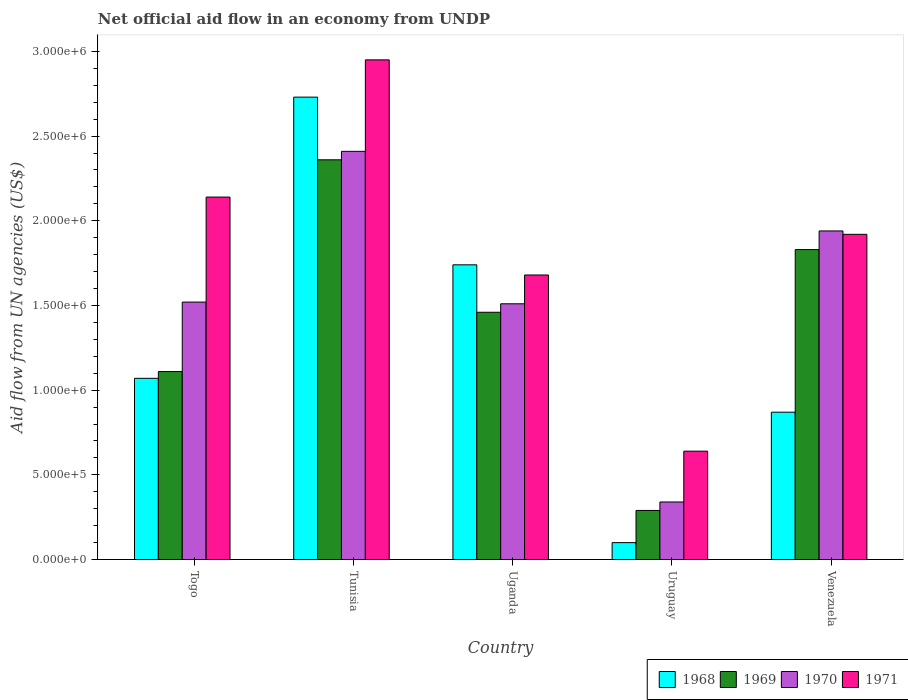How many different coloured bars are there?
Your response must be concise. 4. How many groups of bars are there?
Provide a short and direct response. 5. How many bars are there on the 4th tick from the left?
Your answer should be compact. 4. What is the label of the 5th group of bars from the left?
Provide a short and direct response. Venezuela. What is the net official aid flow in 1971 in Togo?
Ensure brevity in your answer.  2.14e+06. Across all countries, what is the maximum net official aid flow in 1969?
Ensure brevity in your answer.  2.36e+06. Across all countries, what is the minimum net official aid flow in 1971?
Your response must be concise. 6.40e+05. In which country was the net official aid flow in 1971 maximum?
Provide a succinct answer. Tunisia. In which country was the net official aid flow in 1970 minimum?
Offer a terse response. Uruguay. What is the total net official aid flow in 1968 in the graph?
Your answer should be compact. 6.51e+06. What is the difference between the net official aid flow in 1971 in Tunisia and that in Venezuela?
Offer a terse response. 1.03e+06. What is the difference between the net official aid flow in 1970 in Uganda and the net official aid flow in 1971 in Uruguay?
Make the answer very short. 8.70e+05. What is the average net official aid flow in 1968 per country?
Your response must be concise. 1.30e+06. What is the difference between the net official aid flow of/in 1969 and net official aid flow of/in 1971 in Uganda?
Ensure brevity in your answer.  -2.20e+05. What is the ratio of the net official aid flow in 1971 in Tunisia to that in Venezuela?
Offer a terse response. 1.54. Is the net official aid flow in 1968 in Uganda less than that in Venezuela?
Offer a terse response. No. Is the difference between the net official aid flow in 1969 in Togo and Uruguay greater than the difference between the net official aid flow in 1971 in Togo and Uruguay?
Your answer should be very brief. No. What is the difference between the highest and the second highest net official aid flow in 1971?
Offer a very short reply. 1.03e+06. What is the difference between the highest and the lowest net official aid flow in 1969?
Keep it short and to the point. 2.07e+06. Is the sum of the net official aid flow in 1971 in Tunisia and Uruguay greater than the maximum net official aid flow in 1969 across all countries?
Provide a succinct answer. Yes. Is it the case that in every country, the sum of the net official aid flow in 1969 and net official aid flow in 1968 is greater than the sum of net official aid flow in 1970 and net official aid flow in 1971?
Provide a succinct answer. No. What does the 3rd bar from the left in Uruguay represents?
Provide a short and direct response. 1970. Is it the case that in every country, the sum of the net official aid flow in 1969 and net official aid flow in 1970 is greater than the net official aid flow in 1968?
Provide a succinct answer. Yes. How many countries are there in the graph?
Your answer should be very brief. 5. What is the difference between two consecutive major ticks on the Y-axis?
Give a very brief answer. 5.00e+05. Does the graph contain any zero values?
Keep it short and to the point. No. Where does the legend appear in the graph?
Make the answer very short. Bottom right. How are the legend labels stacked?
Your answer should be compact. Horizontal. What is the title of the graph?
Ensure brevity in your answer.  Net official aid flow in an economy from UNDP. What is the label or title of the X-axis?
Your response must be concise. Country. What is the label or title of the Y-axis?
Your answer should be compact. Aid flow from UN agencies (US$). What is the Aid flow from UN agencies (US$) in 1968 in Togo?
Your answer should be very brief. 1.07e+06. What is the Aid flow from UN agencies (US$) in 1969 in Togo?
Your answer should be compact. 1.11e+06. What is the Aid flow from UN agencies (US$) in 1970 in Togo?
Make the answer very short. 1.52e+06. What is the Aid flow from UN agencies (US$) in 1971 in Togo?
Offer a very short reply. 2.14e+06. What is the Aid flow from UN agencies (US$) in 1968 in Tunisia?
Offer a terse response. 2.73e+06. What is the Aid flow from UN agencies (US$) in 1969 in Tunisia?
Your response must be concise. 2.36e+06. What is the Aid flow from UN agencies (US$) in 1970 in Tunisia?
Ensure brevity in your answer.  2.41e+06. What is the Aid flow from UN agencies (US$) of 1971 in Tunisia?
Keep it short and to the point. 2.95e+06. What is the Aid flow from UN agencies (US$) of 1968 in Uganda?
Ensure brevity in your answer.  1.74e+06. What is the Aid flow from UN agencies (US$) in 1969 in Uganda?
Offer a terse response. 1.46e+06. What is the Aid flow from UN agencies (US$) of 1970 in Uganda?
Provide a short and direct response. 1.51e+06. What is the Aid flow from UN agencies (US$) in 1971 in Uganda?
Provide a succinct answer. 1.68e+06. What is the Aid flow from UN agencies (US$) in 1968 in Uruguay?
Keep it short and to the point. 1.00e+05. What is the Aid flow from UN agencies (US$) of 1969 in Uruguay?
Offer a terse response. 2.90e+05. What is the Aid flow from UN agencies (US$) in 1970 in Uruguay?
Your response must be concise. 3.40e+05. What is the Aid flow from UN agencies (US$) of 1971 in Uruguay?
Your response must be concise. 6.40e+05. What is the Aid flow from UN agencies (US$) of 1968 in Venezuela?
Offer a terse response. 8.70e+05. What is the Aid flow from UN agencies (US$) in 1969 in Venezuela?
Your response must be concise. 1.83e+06. What is the Aid flow from UN agencies (US$) in 1970 in Venezuela?
Provide a short and direct response. 1.94e+06. What is the Aid flow from UN agencies (US$) in 1971 in Venezuela?
Offer a terse response. 1.92e+06. Across all countries, what is the maximum Aid flow from UN agencies (US$) in 1968?
Make the answer very short. 2.73e+06. Across all countries, what is the maximum Aid flow from UN agencies (US$) of 1969?
Your answer should be compact. 2.36e+06. Across all countries, what is the maximum Aid flow from UN agencies (US$) of 1970?
Offer a very short reply. 2.41e+06. Across all countries, what is the maximum Aid flow from UN agencies (US$) in 1971?
Ensure brevity in your answer.  2.95e+06. Across all countries, what is the minimum Aid flow from UN agencies (US$) in 1968?
Give a very brief answer. 1.00e+05. Across all countries, what is the minimum Aid flow from UN agencies (US$) of 1969?
Offer a very short reply. 2.90e+05. Across all countries, what is the minimum Aid flow from UN agencies (US$) in 1971?
Make the answer very short. 6.40e+05. What is the total Aid flow from UN agencies (US$) in 1968 in the graph?
Provide a succinct answer. 6.51e+06. What is the total Aid flow from UN agencies (US$) of 1969 in the graph?
Provide a succinct answer. 7.05e+06. What is the total Aid flow from UN agencies (US$) of 1970 in the graph?
Provide a succinct answer. 7.72e+06. What is the total Aid flow from UN agencies (US$) of 1971 in the graph?
Provide a short and direct response. 9.33e+06. What is the difference between the Aid flow from UN agencies (US$) in 1968 in Togo and that in Tunisia?
Offer a very short reply. -1.66e+06. What is the difference between the Aid flow from UN agencies (US$) of 1969 in Togo and that in Tunisia?
Give a very brief answer. -1.25e+06. What is the difference between the Aid flow from UN agencies (US$) in 1970 in Togo and that in Tunisia?
Give a very brief answer. -8.90e+05. What is the difference between the Aid flow from UN agencies (US$) of 1971 in Togo and that in Tunisia?
Provide a succinct answer. -8.10e+05. What is the difference between the Aid flow from UN agencies (US$) in 1968 in Togo and that in Uganda?
Provide a short and direct response. -6.70e+05. What is the difference between the Aid flow from UN agencies (US$) of 1969 in Togo and that in Uganda?
Your response must be concise. -3.50e+05. What is the difference between the Aid flow from UN agencies (US$) in 1970 in Togo and that in Uganda?
Make the answer very short. 10000. What is the difference between the Aid flow from UN agencies (US$) in 1971 in Togo and that in Uganda?
Provide a short and direct response. 4.60e+05. What is the difference between the Aid flow from UN agencies (US$) of 1968 in Togo and that in Uruguay?
Provide a succinct answer. 9.70e+05. What is the difference between the Aid flow from UN agencies (US$) in 1969 in Togo and that in Uruguay?
Your answer should be compact. 8.20e+05. What is the difference between the Aid flow from UN agencies (US$) in 1970 in Togo and that in Uruguay?
Keep it short and to the point. 1.18e+06. What is the difference between the Aid flow from UN agencies (US$) in 1971 in Togo and that in Uruguay?
Your answer should be very brief. 1.50e+06. What is the difference between the Aid flow from UN agencies (US$) of 1969 in Togo and that in Venezuela?
Your answer should be compact. -7.20e+05. What is the difference between the Aid flow from UN agencies (US$) of 1970 in Togo and that in Venezuela?
Give a very brief answer. -4.20e+05. What is the difference between the Aid flow from UN agencies (US$) in 1968 in Tunisia and that in Uganda?
Keep it short and to the point. 9.90e+05. What is the difference between the Aid flow from UN agencies (US$) of 1970 in Tunisia and that in Uganda?
Provide a succinct answer. 9.00e+05. What is the difference between the Aid flow from UN agencies (US$) of 1971 in Tunisia and that in Uganda?
Your answer should be compact. 1.27e+06. What is the difference between the Aid flow from UN agencies (US$) in 1968 in Tunisia and that in Uruguay?
Your answer should be very brief. 2.63e+06. What is the difference between the Aid flow from UN agencies (US$) in 1969 in Tunisia and that in Uruguay?
Make the answer very short. 2.07e+06. What is the difference between the Aid flow from UN agencies (US$) of 1970 in Tunisia and that in Uruguay?
Ensure brevity in your answer.  2.07e+06. What is the difference between the Aid flow from UN agencies (US$) of 1971 in Tunisia and that in Uruguay?
Your answer should be very brief. 2.31e+06. What is the difference between the Aid flow from UN agencies (US$) of 1968 in Tunisia and that in Venezuela?
Your answer should be very brief. 1.86e+06. What is the difference between the Aid flow from UN agencies (US$) in 1969 in Tunisia and that in Venezuela?
Ensure brevity in your answer.  5.30e+05. What is the difference between the Aid flow from UN agencies (US$) of 1971 in Tunisia and that in Venezuela?
Ensure brevity in your answer.  1.03e+06. What is the difference between the Aid flow from UN agencies (US$) in 1968 in Uganda and that in Uruguay?
Keep it short and to the point. 1.64e+06. What is the difference between the Aid flow from UN agencies (US$) in 1969 in Uganda and that in Uruguay?
Keep it short and to the point. 1.17e+06. What is the difference between the Aid flow from UN agencies (US$) in 1970 in Uganda and that in Uruguay?
Make the answer very short. 1.17e+06. What is the difference between the Aid flow from UN agencies (US$) in 1971 in Uganda and that in Uruguay?
Offer a very short reply. 1.04e+06. What is the difference between the Aid flow from UN agencies (US$) in 1968 in Uganda and that in Venezuela?
Offer a very short reply. 8.70e+05. What is the difference between the Aid flow from UN agencies (US$) of 1969 in Uganda and that in Venezuela?
Offer a very short reply. -3.70e+05. What is the difference between the Aid flow from UN agencies (US$) of 1970 in Uganda and that in Venezuela?
Make the answer very short. -4.30e+05. What is the difference between the Aid flow from UN agencies (US$) of 1968 in Uruguay and that in Venezuela?
Your answer should be compact. -7.70e+05. What is the difference between the Aid flow from UN agencies (US$) in 1969 in Uruguay and that in Venezuela?
Your answer should be compact. -1.54e+06. What is the difference between the Aid flow from UN agencies (US$) in 1970 in Uruguay and that in Venezuela?
Ensure brevity in your answer.  -1.60e+06. What is the difference between the Aid flow from UN agencies (US$) of 1971 in Uruguay and that in Venezuela?
Provide a succinct answer. -1.28e+06. What is the difference between the Aid flow from UN agencies (US$) in 1968 in Togo and the Aid flow from UN agencies (US$) in 1969 in Tunisia?
Give a very brief answer. -1.29e+06. What is the difference between the Aid flow from UN agencies (US$) of 1968 in Togo and the Aid flow from UN agencies (US$) of 1970 in Tunisia?
Ensure brevity in your answer.  -1.34e+06. What is the difference between the Aid flow from UN agencies (US$) of 1968 in Togo and the Aid flow from UN agencies (US$) of 1971 in Tunisia?
Your response must be concise. -1.88e+06. What is the difference between the Aid flow from UN agencies (US$) of 1969 in Togo and the Aid flow from UN agencies (US$) of 1970 in Tunisia?
Offer a terse response. -1.30e+06. What is the difference between the Aid flow from UN agencies (US$) of 1969 in Togo and the Aid flow from UN agencies (US$) of 1971 in Tunisia?
Offer a very short reply. -1.84e+06. What is the difference between the Aid flow from UN agencies (US$) of 1970 in Togo and the Aid flow from UN agencies (US$) of 1971 in Tunisia?
Your answer should be compact. -1.43e+06. What is the difference between the Aid flow from UN agencies (US$) in 1968 in Togo and the Aid flow from UN agencies (US$) in 1969 in Uganda?
Make the answer very short. -3.90e+05. What is the difference between the Aid flow from UN agencies (US$) of 1968 in Togo and the Aid flow from UN agencies (US$) of 1970 in Uganda?
Give a very brief answer. -4.40e+05. What is the difference between the Aid flow from UN agencies (US$) in 1968 in Togo and the Aid flow from UN agencies (US$) in 1971 in Uganda?
Offer a terse response. -6.10e+05. What is the difference between the Aid flow from UN agencies (US$) in 1969 in Togo and the Aid flow from UN agencies (US$) in 1970 in Uganda?
Give a very brief answer. -4.00e+05. What is the difference between the Aid flow from UN agencies (US$) of 1969 in Togo and the Aid flow from UN agencies (US$) of 1971 in Uganda?
Offer a terse response. -5.70e+05. What is the difference between the Aid flow from UN agencies (US$) in 1970 in Togo and the Aid flow from UN agencies (US$) in 1971 in Uganda?
Give a very brief answer. -1.60e+05. What is the difference between the Aid flow from UN agencies (US$) in 1968 in Togo and the Aid flow from UN agencies (US$) in 1969 in Uruguay?
Your answer should be very brief. 7.80e+05. What is the difference between the Aid flow from UN agencies (US$) of 1968 in Togo and the Aid flow from UN agencies (US$) of 1970 in Uruguay?
Your answer should be compact. 7.30e+05. What is the difference between the Aid flow from UN agencies (US$) in 1969 in Togo and the Aid flow from UN agencies (US$) in 1970 in Uruguay?
Your answer should be compact. 7.70e+05. What is the difference between the Aid flow from UN agencies (US$) in 1969 in Togo and the Aid flow from UN agencies (US$) in 1971 in Uruguay?
Offer a terse response. 4.70e+05. What is the difference between the Aid flow from UN agencies (US$) in 1970 in Togo and the Aid flow from UN agencies (US$) in 1971 in Uruguay?
Give a very brief answer. 8.80e+05. What is the difference between the Aid flow from UN agencies (US$) in 1968 in Togo and the Aid flow from UN agencies (US$) in 1969 in Venezuela?
Your answer should be very brief. -7.60e+05. What is the difference between the Aid flow from UN agencies (US$) of 1968 in Togo and the Aid flow from UN agencies (US$) of 1970 in Venezuela?
Give a very brief answer. -8.70e+05. What is the difference between the Aid flow from UN agencies (US$) in 1968 in Togo and the Aid flow from UN agencies (US$) in 1971 in Venezuela?
Ensure brevity in your answer.  -8.50e+05. What is the difference between the Aid flow from UN agencies (US$) of 1969 in Togo and the Aid flow from UN agencies (US$) of 1970 in Venezuela?
Your answer should be compact. -8.30e+05. What is the difference between the Aid flow from UN agencies (US$) in 1969 in Togo and the Aid flow from UN agencies (US$) in 1971 in Venezuela?
Your response must be concise. -8.10e+05. What is the difference between the Aid flow from UN agencies (US$) of 1970 in Togo and the Aid flow from UN agencies (US$) of 1971 in Venezuela?
Your answer should be very brief. -4.00e+05. What is the difference between the Aid flow from UN agencies (US$) of 1968 in Tunisia and the Aid flow from UN agencies (US$) of 1969 in Uganda?
Keep it short and to the point. 1.27e+06. What is the difference between the Aid flow from UN agencies (US$) of 1968 in Tunisia and the Aid flow from UN agencies (US$) of 1970 in Uganda?
Keep it short and to the point. 1.22e+06. What is the difference between the Aid flow from UN agencies (US$) of 1968 in Tunisia and the Aid flow from UN agencies (US$) of 1971 in Uganda?
Make the answer very short. 1.05e+06. What is the difference between the Aid flow from UN agencies (US$) in 1969 in Tunisia and the Aid flow from UN agencies (US$) in 1970 in Uganda?
Ensure brevity in your answer.  8.50e+05. What is the difference between the Aid flow from UN agencies (US$) of 1969 in Tunisia and the Aid flow from UN agencies (US$) of 1971 in Uganda?
Your answer should be very brief. 6.80e+05. What is the difference between the Aid flow from UN agencies (US$) of 1970 in Tunisia and the Aid flow from UN agencies (US$) of 1971 in Uganda?
Make the answer very short. 7.30e+05. What is the difference between the Aid flow from UN agencies (US$) of 1968 in Tunisia and the Aid flow from UN agencies (US$) of 1969 in Uruguay?
Make the answer very short. 2.44e+06. What is the difference between the Aid flow from UN agencies (US$) of 1968 in Tunisia and the Aid flow from UN agencies (US$) of 1970 in Uruguay?
Your answer should be very brief. 2.39e+06. What is the difference between the Aid flow from UN agencies (US$) of 1968 in Tunisia and the Aid flow from UN agencies (US$) of 1971 in Uruguay?
Your response must be concise. 2.09e+06. What is the difference between the Aid flow from UN agencies (US$) in 1969 in Tunisia and the Aid flow from UN agencies (US$) in 1970 in Uruguay?
Keep it short and to the point. 2.02e+06. What is the difference between the Aid flow from UN agencies (US$) of 1969 in Tunisia and the Aid flow from UN agencies (US$) of 1971 in Uruguay?
Your answer should be compact. 1.72e+06. What is the difference between the Aid flow from UN agencies (US$) in 1970 in Tunisia and the Aid flow from UN agencies (US$) in 1971 in Uruguay?
Ensure brevity in your answer.  1.77e+06. What is the difference between the Aid flow from UN agencies (US$) of 1968 in Tunisia and the Aid flow from UN agencies (US$) of 1970 in Venezuela?
Give a very brief answer. 7.90e+05. What is the difference between the Aid flow from UN agencies (US$) of 1968 in Tunisia and the Aid flow from UN agencies (US$) of 1971 in Venezuela?
Provide a short and direct response. 8.10e+05. What is the difference between the Aid flow from UN agencies (US$) of 1969 in Tunisia and the Aid flow from UN agencies (US$) of 1970 in Venezuela?
Offer a very short reply. 4.20e+05. What is the difference between the Aid flow from UN agencies (US$) in 1969 in Tunisia and the Aid flow from UN agencies (US$) in 1971 in Venezuela?
Offer a very short reply. 4.40e+05. What is the difference between the Aid flow from UN agencies (US$) in 1970 in Tunisia and the Aid flow from UN agencies (US$) in 1971 in Venezuela?
Make the answer very short. 4.90e+05. What is the difference between the Aid flow from UN agencies (US$) of 1968 in Uganda and the Aid flow from UN agencies (US$) of 1969 in Uruguay?
Ensure brevity in your answer.  1.45e+06. What is the difference between the Aid flow from UN agencies (US$) of 1968 in Uganda and the Aid flow from UN agencies (US$) of 1970 in Uruguay?
Your answer should be compact. 1.40e+06. What is the difference between the Aid flow from UN agencies (US$) of 1968 in Uganda and the Aid flow from UN agencies (US$) of 1971 in Uruguay?
Your answer should be compact. 1.10e+06. What is the difference between the Aid flow from UN agencies (US$) of 1969 in Uganda and the Aid flow from UN agencies (US$) of 1970 in Uruguay?
Give a very brief answer. 1.12e+06. What is the difference between the Aid flow from UN agencies (US$) of 1969 in Uganda and the Aid flow from UN agencies (US$) of 1971 in Uruguay?
Keep it short and to the point. 8.20e+05. What is the difference between the Aid flow from UN agencies (US$) in 1970 in Uganda and the Aid flow from UN agencies (US$) in 1971 in Uruguay?
Your answer should be very brief. 8.70e+05. What is the difference between the Aid flow from UN agencies (US$) of 1968 in Uganda and the Aid flow from UN agencies (US$) of 1971 in Venezuela?
Give a very brief answer. -1.80e+05. What is the difference between the Aid flow from UN agencies (US$) in 1969 in Uganda and the Aid flow from UN agencies (US$) in 1970 in Venezuela?
Your answer should be very brief. -4.80e+05. What is the difference between the Aid flow from UN agencies (US$) in 1969 in Uganda and the Aid flow from UN agencies (US$) in 1971 in Venezuela?
Your response must be concise. -4.60e+05. What is the difference between the Aid flow from UN agencies (US$) of 1970 in Uganda and the Aid flow from UN agencies (US$) of 1971 in Venezuela?
Keep it short and to the point. -4.10e+05. What is the difference between the Aid flow from UN agencies (US$) in 1968 in Uruguay and the Aid flow from UN agencies (US$) in 1969 in Venezuela?
Keep it short and to the point. -1.73e+06. What is the difference between the Aid flow from UN agencies (US$) in 1968 in Uruguay and the Aid flow from UN agencies (US$) in 1970 in Venezuela?
Provide a succinct answer. -1.84e+06. What is the difference between the Aid flow from UN agencies (US$) in 1968 in Uruguay and the Aid flow from UN agencies (US$) in 1971 in Venezuela?
Your response must be concise. -1.82e+06. What is the difference between the Aid flow from UN agencies (US$) of 1969 in Uruguay and the Aid flow from UN agencies (US$) of 1970 in Venezuela?
Provide a short and direct response. -1.65e+06. What is the difference between the Aid flow from UN agencies (US$) of 1969 in Uruguay and the Aid flow from UN agencies (US$) of 1971 in Venezuela?
Provide a succinct answer. -1.63e+06. What is the difference between the Aid flow from UN agencies (US$) in 1970 in Uruguay and the Aid flow from UN agencies (US$) in 1971 in Venezuela?
Keep it short and to the point. -1.58e+06. What is the average Aid flow from UN agencies (US$) of 1968 per country?
Provide a short and direct response. 1.30e+06. What is the average Aid flow from UN agencies (US$) in 1969 per country?
Offer a terse response. 1.41e+06. What is the average Aid flow from UN agencies (US$) of 1970 per country?
Make the answer very short. 1.54e+06. What is the average Aid flow from UN agencies (US$) of 1971 per country?
Offer a terse response. 1.87e+06. What is the difference between the Aid flow from UN agencies (US$) of 1968 and Aid flow from UN agencies (US$) of 1970 in Togo?
Your response must be concise. -4.50e+05. What is the difference between the Aid flow from UN agencies (US$) of 1968 and Aid flow from UN agencies (US$) of 1971 in Togo?
Provide a succinct answer. -1.07e+06. What is the difference between the Aid flow from UN agencies (US$) in 1969 and Aid flow from UN agencies (US$) in 1970 in Togo?
Your response must be concise. -4.10e+05. What is the difference between the Aid flow from UN agencies (US$) in 1969 and Aid flow from UN agencies (US$) in 1971 in Togo?
Make the answer very short. -1.03e+06. What is the difference between the Aid flow from UN agencies (US$) in 1970 and Aid flow from UN agencies (US$) in 1971 in Togo?
Give a very brief answer. -6.20e+05. What is the difference between the Aid flow from UN agencies (US$) in 1968 and Aid flow from UN agencies (US$) in 1970 in Tunisia?
Offer a very short reply. 3.20e+05. What is the difference between the Aid flow from UN agencies (US$) of 1968 and Aid flow from UN agencies (US$) of 1971 in Tunisia?
Give a very brief answer. -2.20e+05. What is the difference between the Aid flow from UN agencies (US$) of 1969 and Aid flow from UN agencies (US$) of 1971 in Tunisia?
Your response must be concise. -5.90e+05. What is the difference between the Aid flow from UN agencies (US$) in 1970 and Aid flow from UN agencies (US$) in 1971 in Tunisia?
Offer a terse response. -5.40e+05. What is the difference between the Aid flow from UN agencies (US$) in 1968 and Aid flow from UN agencies (US$) in 1969 in Uganda?
Offer a very short reply. 2.80e+05. What is the difference between the Aid flow from UN agencies (US$) in 1968 and Aid flow from UN agencies (US$) in 1971 in Uganda?
Give a very brief answer. 6.00e+04. What is the difference between the Aid flow from UN agencies (US$) in 1969 and Aid flow from UN agencies (US$) in 1970 in Uganda?
Ensure brevity in your answer.  -5.00e+04. What is the difference between the Aid flow from UN agencies (US$) of 1969 and Aid flow from UN agencies (US$) of 1971 in Uganda?
Your answer should be compact. -2.20e+05. What is the difference between the Aid flow from UN agencies (US$) in 1970 and Aid flow from UN agencies (US$) in 1971 in Uganda?
Ensure brevity in your answer.  -1.70e+05. What is the difference between the Aid flow from UN agencies (US$) of 1968 and Aid flow from UN agencies (US$) of 1970 in Uruguay?
Provide a succinct answer. -2.40e+05. What is the difference between the Aid flow from UN agencies (US$) of 1968 and Aid flow from UN agencies (US$) of 1971 in Uruguay?
Your answer should be compact. -5.40e+05. What is the difference between the Aid flow from UN agencies (US$) in 1969 and Aid flow from UN agencies (US$) in 1971 in Uruguay?
Provide a succinct answer. -3.50e+05. What is the difference between the Aid flow from UN agencies (US$) of 1970 and Aid flow from UN agencies (US$) of 1971 in Uruguay?
Provide a succinct answer. -3.00e+05. What is the difference between the Aid flow from UN agencies (US$) of 1968 and Aid flow from UN agencies (US$) of 1969 in Venezuela?
Offer a terse response. -9.60e+05. What is the difference between the Aid flow from UN agencies (US$) in 1968 and Aid flow from UN agencies (US$) in 1970 in Venezuela?
Offer a terse response. -1.07e+06. What is the difference between the Aid flow from UN agencies (US$) of 1968 and Aid flow from UN agencies (US$) of 1971 in Venezuela?
Provide a succinct answer. -1.05e+06. What is the difference between the Aid flow from UN agencies (US$) in 1969 and Aid flow from UN agencies (US$) in 1970 in Venezuela?
Offer a terse response. -1.10e+05. What is the difference between the Aid flow from UN agencies (US$) of 1969 and Aid flow from UN agencies (US$) of 1971 in Venezuela?
Give a very brief answer. -9.00e+04. What is the ratio of the Aid flow from UN agencies (US$) of 1968 in Togo to that in Tunisia?
Ensure brevity in your answer.  0.39. What is the ratio of the Aid flow from UN agencies (US$) in 1969 in Togo to that in Tunisia?
Give a very brief answer. 0.47. What is the ratio of the Aid flow from UN agencies (US$) of 1970 in Togo to that in Tunisia?
Provide a succinct answer. 0.63. What is the ratio of the Aid flow from UN agencies (US$) of 1971 in Togo to that in Tunisia?
Offer a terse response. 0.73. What is the ratio of the Aid flow from UN agencies (US$) in 1968 in Togo to that in Uganda?
Offer a very short reply. 0.61. What is the ratio of the Aid flow from UN agencies (US$) of 1969 in Togo to that in Uganda?
Make the answer very short. 0.76. What is the ratio of the Aid flow from UN agencies (US$) in 1970 in Togo to that in Uganda?
Make the answer very short. 1.01. What is the ratio of the Aid flow from UN agencies (US$) of 1971 in Togo to that in Uganda?
Your answer should be very brief. 1.27. What is the ratio of the Aid flow from UN agencies (US$) of 1968 in Togo to that in Uruguay?
Your answer should be compact. 10.7. What is the ratio of the Aid flow from UN agencies (US$) of 1969 in Togo to that in Uruguay?
Offer a terse response. 3.83. What is the ratio of the Aid flow from UN agencies (US$) in 1970 in Togo to that in Uruguay?
Your answer should be compact. 4.47. What is the ratio of the Aid flow from UN agencies (US$) in 1971 in Togo to that in Uruguay?
Keep it short and to the point. 3.34. What is the ratio of the Aid flow from UN agencies (US$) in 1968 in Togo to that in Venezuela?
Provide a short and direct response. 1.23. What is the ratio of the Aid flow from UN agencies (US$) in 1969 in Togo to that in Venezuela?
Give a very brief answer. 0.61. What is the ratio of the Aid flow from UN agencies (US$) of 1970 in Togo to that in Venezuela?
Your response must be concise. 0.78. What is the ratio of the Aid flow from UN agencies (US$) of 1971 in Togo to that in Venezuela?
Provide a short and direct response. 1.11. What is the ratio of the Aid flow from UN agencies (US$) of 1968 in Tunisia to that in Uganda?
Keep it short and to the point. 1.57. What is the ratio of the Aid flow from UN agencies (US$) of 1969 in Tunisia to that in Uganda?
Provide a short and direct response. 1.62. What is the ratio of the Aid flow from UN agencies (US$) of 1970 in Tunisia to that in Uganda?
Provide a succinct answer. 1.6. What is the ratio of the Aid flow from UN agencies (US$) in 1971 in Tunisia to that in Uganda?
Make the answer very short. 1.76. What is the ratio of the Aid flow from UN agencies (US$) of 1968 in Tunisia to that in Uruguay?
Make the answer very short. 27.3. What is the ratio of the Aid flow from UN agencies (US$) of 1969 in Tunisia to that in Uruguay?
Offer a very short reply. 8.14. What is the ratio of the Aid flow from UN agencies (US$) in 1970 in Tunisia to that in Uruguay?
Provide a short and direct response. 7.09. What is the ratio of the Aid flow from UN agencies (US$) of 1971 in Tunisia to that in Uruguay?
Ensure brevity in your answer.  4.61. What is the ratio of the Aid flow from UN agencies (US$) of 1968 in Tunisia to that in Venezuela?
Your response must be concise. 3.14. What is the ratio of the Aid flow from UN agencies (US$) in 1969 in Tunisia to that in Venezuela?
Provide a short and direct response. 1.29. What is the ratio of the Aid flow from UN agencies (US$) in 1970 in Tunisia to that in Venezuela?
Offer a very short reply. 1.24. What is the ratio of the Aid flow from UN agencies (US$) of 1971 in Tunisia to that in Venezuela?
Your response must be concise. 1.54. What is the ratio of the Aid flow from UN agencies (US$) in 1968 in Uganda to that in Uruguay?
Give a very brief answer. 17.4. What is the ratio of the Aid flow from UN agencies (US$) of 1969 in Uganda to that in Uruguay?
Provide a succinct answer. 5.03. What is the ratio of the Aid flow from UN agencies (US$) of 1970 in Uganda to that in Uruguay?
Keep it short and to the point. 4.44. What is the ratio of the Aid flow from UN agencies (US$) of 1971 in Uganda to that in Uruguay?
Provide a short and direct response. 2.62. What is the ratio of the Aid flow from UN agencies (US$) in 1968 in Uganda to that in Venezuela?
Keep it short and to the point. 2. What is the ratio of the Aid flow from UN agencies (US$) in 1969 in Uganda to that in Venezuela?
Offer a terse response. 0.8. What is the ratio of the Aid flow from UN agencies (US$) in 1970 in Uganda to that in Venezuela?
Ensure brevity in your answer.  0.78. What is the ratio of the Aid flow from UN agencies (US$) of 1971 in Uganda to that in Venezuela?
Offer a terse response. 0.88. What is the ratio of the Aid flow from UN agencies (US$) of 1968 in Uruguay to that in Venezuela?
Make the answer very short. 0.11. What is the ratio of the Aid flow from UN agencies (US$) in 1969 in Uruguay to that in Venezuela?
Give a very brief answer. 0.16. What is the ratio of the Aid flow from UN agencies (US$) in 1970 in Uruguay to that in Venezuela?
Provide a succinct answer. 0.18. What is the ratio of the Aid flow from UN agencies (US$) in 1971 in Uruguay to that in Venezuela?
Your response must be concise. 0.33. What is the difference between the highest and the second highest Aid flow from UN agencies (US$) of 1968?
Your response must be concise. 9.90e+05. What is the difference between the highest and the second highest Aid flow from UN agencies (US$) in 1969?
Your answer should be very brief. 5.30e+05. What is the difference between the highest and the second highest Aid flow from UN agencies (US$) in 1970?
Offer a very short reply. 4.70e+05. What is the difference between the highest and the second highest Aid flow from UN agencies (US$) in 1971?
Ensure brevity in your answer.  8.10e+05. What is the difference between the highest and the lowest Aid flow from UN agencies (US$) of 1968?
Provide a short and direct response. 2.63e+06. What is the difference between the highest and the lowest Aid flow from UN agencies (US$) in 1969?
Your response must be concise. 2.07e+06. What is the difference between the highest and the lowest Aid flow from UN agencies (US$) in 1970?
Keep it short and to the point. 2.07e+06. What is the difference between the highest and the lowest Aid flow from UN agencies (US$) in 1971?
Your response must be concise. 2.31e+06. 